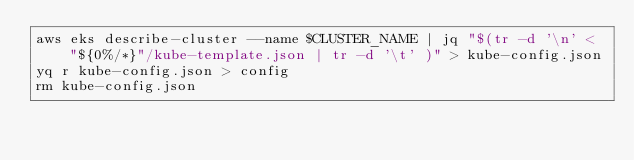<code> <loc_0><loc_0><loc_500><loc_500><_Bash_>aws eks describe-cluster --name $CLUSTER_NAME | jq "$(tr -d '\n' < "${0%/*}"/kube-template.json | tr -d '\t' )" > kube-config.json
yq r kube-config.json > config
rm kube-config.json</code> 